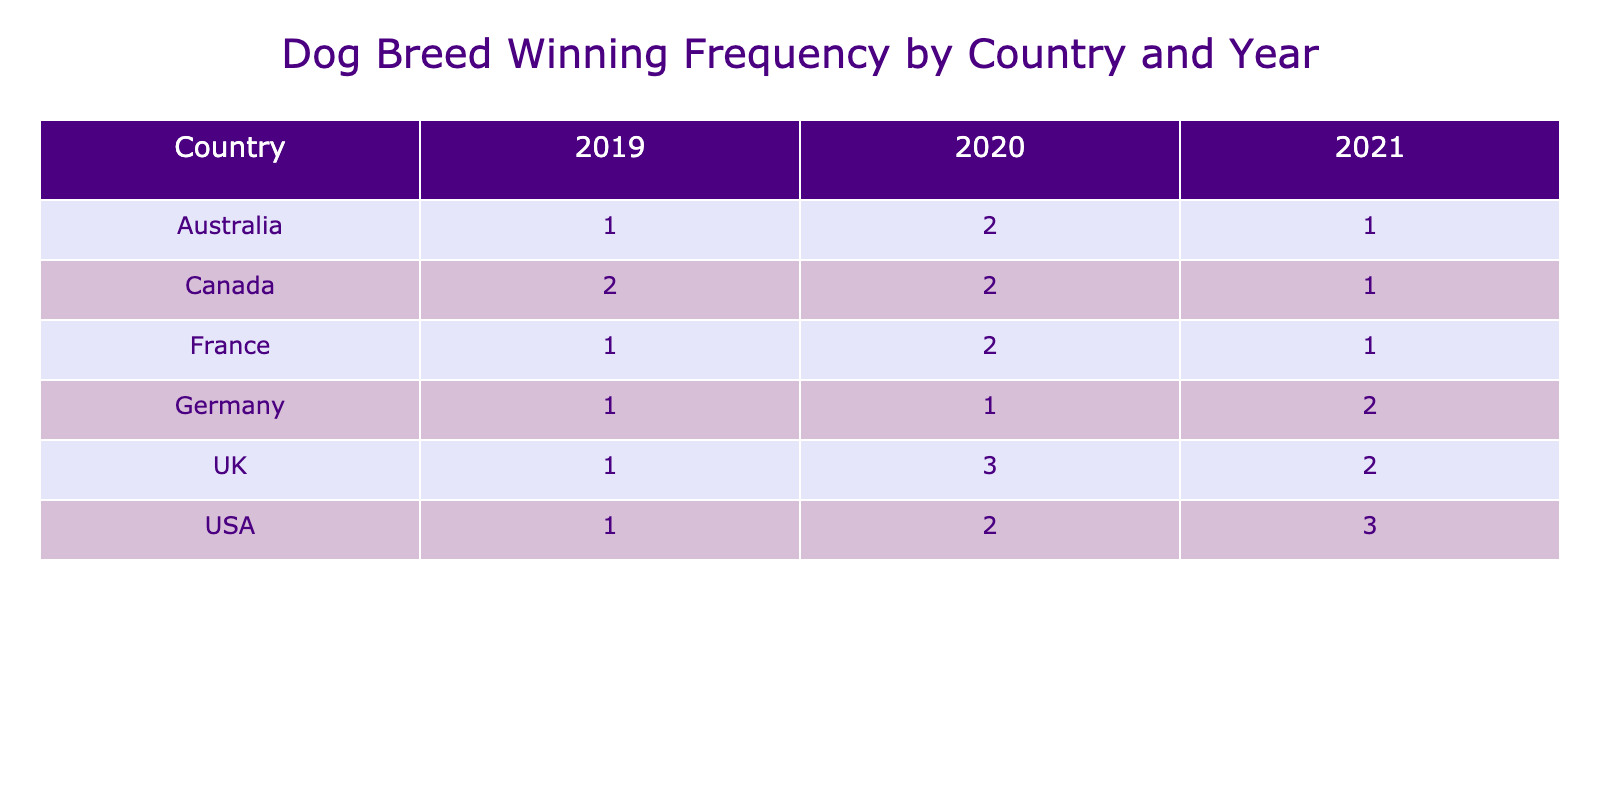What dog breed won the most frequently in the USA in 2021? The table shows the winning frequency of various dog breeds in different years and countries. For the USA in 2021, the winning breed was the Labrador Retriever with a frequency of 3.
Answer: Labrador Retriever Which country had the highest winning frequency in 2020? To find out which country had the highest winning frequency in 2020, I will check the sums for each country in that year. USA had 2, UK had 3, Canada had 2, Australia had 2, Germany had 1, and France had 2. The UK has the highest frequency with a total of 3.
Answer: UK How many total wins did German breeds achieve across all years? The table indicates that in Germany, the Rottweiler won 2 times in 2021, the Yorkshire Terrier won 1 time in 2020, and the Boxer won 1 time in 2019. Summing these gives 2 + 1 + 1 = 4 wins total for German breeds.
Answer: 4 Was there a year when the Cavalier King Charles Spaniel won in the UK? The data shows that the Cavalier King Charles Spaniel won 2 times in the UK during 2021. Therefore, it confirms that there was indeed a win for this breed in that year.
Answer: Yes Which breed had the lowest winning frequency in France across all years? In France, the winning frequencies were for Bichon Frise (1 in 2021), Beagle (2 in 2020), and Miniature Schnauzer (1 in 2019). Both the Bichon Frise and the Miniature Schnauzer had the lowest frequency of 1, but since they are tied, both can be considered as having the lowest.
Answer: Bichon Frise and Miniature Schnauzer What is the total winning frequency of the Siberian Husky? The Siberian Husky won 1 time in Canada in 2021. Thus, its total winning frequency is just 1 for that year.
Answer: 1 Which breed won the least frequently in Australia across all years? In Australia, the winning frequencies are as follows: Australian Shepherd (1 in 2021), Border Collie (2 in 2020), and Staffordshire Bull Terrier (1 in 2019). The Australian Shepherd and Staffordshire Bull Terrier both had a frequency of 1, hence they had the least wins in Australia across the years.
Answer: Australian Shepherd and Staffordshire Bull Terrier How many more wins did the English Bulldog have compared to the Labrador Retriever in 2020? The English Bulldog won 3 times in the UK in 2020 while the Labrador Retriever won 0 times (not mentioned) that year. Thus, the difference in their winning frequencies is 3 - 0 = 3.
Answer: 3 What is the average winning frequency of breeds from Canada? In Canada, the winning frequencies are: Siberian Husky (1), Dachshund (2), and Poodle (2). To find the average, sum these: 1 + 2 + 2 = 5. Then divide by 3 (the number of breeds), yielding an average of 5 / 3 ≈ 1.67.
Answer: 1.67 